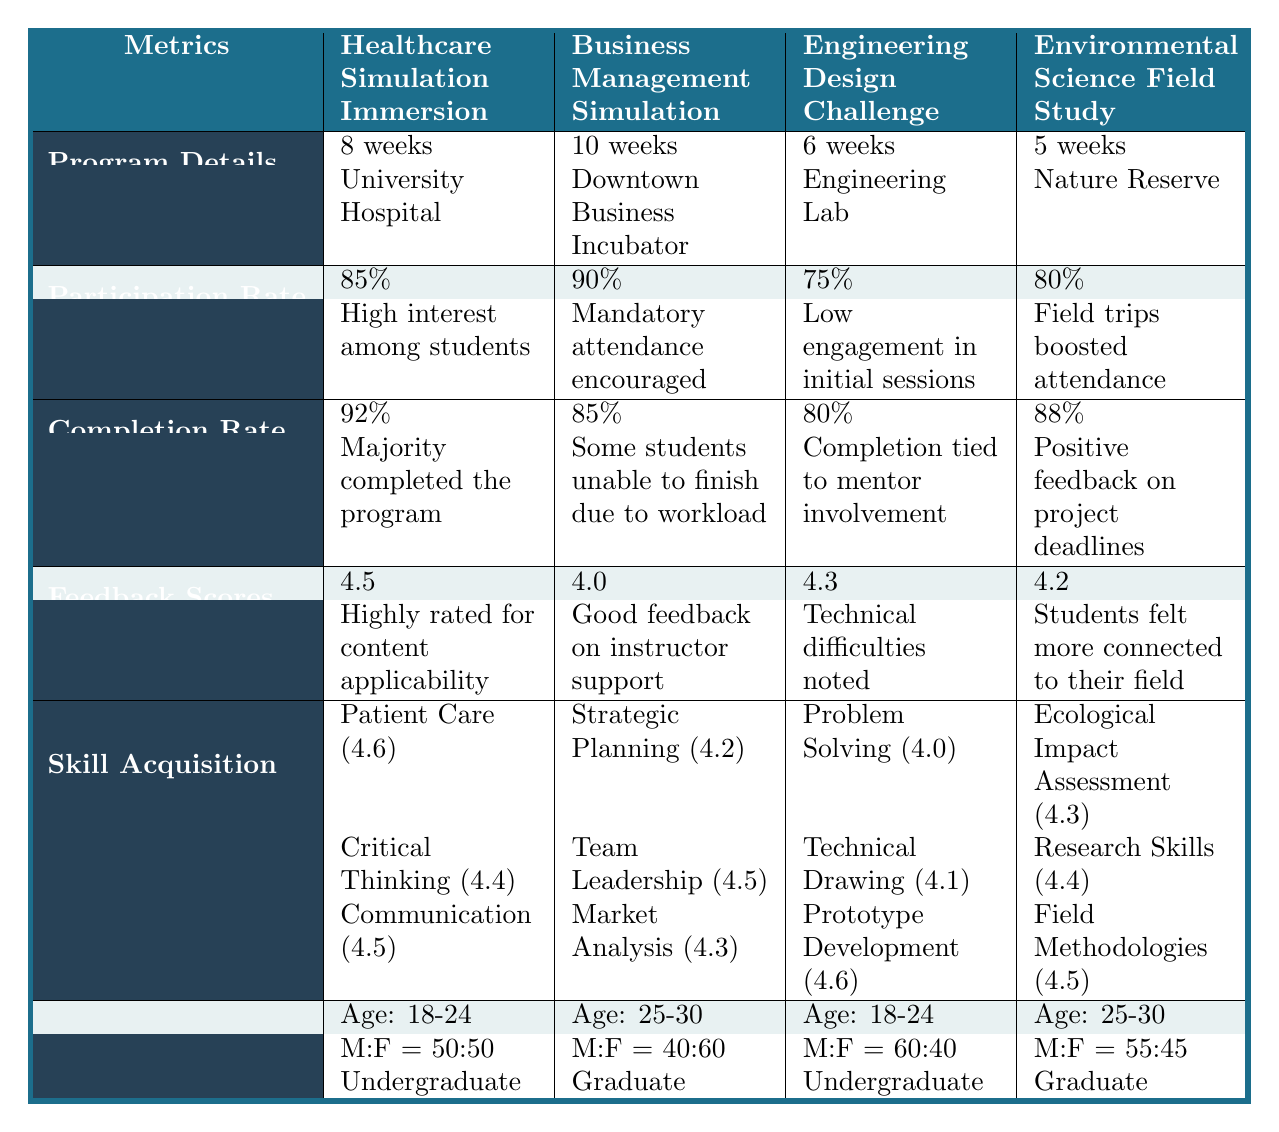What is the participation rate for the Business Management Simulation program? According to the table, the participation rate for the Business Management Simulation program is listed under the Participation Rate row, which shows 90%.
Answer: 90% Which program has the highest completion rate and what is that rate? The completion rates for the programs are 92%, 85%, 80%, and 88%. Comparing these values, the Healthcare Simulation Immersion has the highest completion rate of 92%.
Answer: 92% What skills were acquired in the Engineering Design Challenge program? The table lists the skills gained in the Engineering Design Challenge program under Skill Acquisition as Problem Solving, Technical Drawing, and Prototype Development.
Answer: Problem Solving, Technical Drawing, Prototype Development Is the average feedback score for the Healthcare Simulation Immersion program greater than 4.4? The average feedback score for the Healthcare Simulation Immersion is listed as 4.5, which is indeed greater than 4.4.
Answer: Yes What is the average skill rating across all skills for the Environmental Science Field Study program? The skill ratings for the Environmental Science Field Study program are 4.3, 4.4, and 4.5. Adding these ratings gives 4.3 + 4.4 + 4.5 = 13.2, and dividing by the number of skills (3) gives 13.2 / 3 = 4.4 as the average.
Answer: 4.4 Do more male or female students participate in the Healthcare Simulation Immersion? For the Healthcare Simulation Immersion program, the gender ratio is equal, with 50 male and 50 female students, meaning there are equal numbers.
Answer: Equal Which program has the lowest participation rate and what can you infer about it from the comments? The Engineering Design Challenge program has the lowest participation rate of 75%. The comment indicates low engagement in initial sessions, suggesting that students may not have found the first sessions motivating or engaging.
Answer: Engineering Design Challenge, low engagement in initial sessions If I wanted to compare completion rates, how many more percentage points does the Healthcare Simulation Immersion surpass the Engineering Design Challenge? The completion rate for Healthcare Simulation Immersion is 92%, and the rate for Engineering Design Challenge is 80%. Subtracting these values gives 92% - 80% = 12%, showing that the Healthcare Simulation Immersion surpasses it by 12 percentage points.
Answer: 12% Which location corresponds to the Business Management Simulation program? The location for the Business Management Simulation program is noted in the Location row as Downtown Business Incubator.
Answer: Downtown Business Incubator Is there any program where the male to female ratio is equal? The only program where the male to female ratio is equal occurs in the Healthcare Simulation Immersion program, as it has 50 males and 50 females.
Answer: Yes 